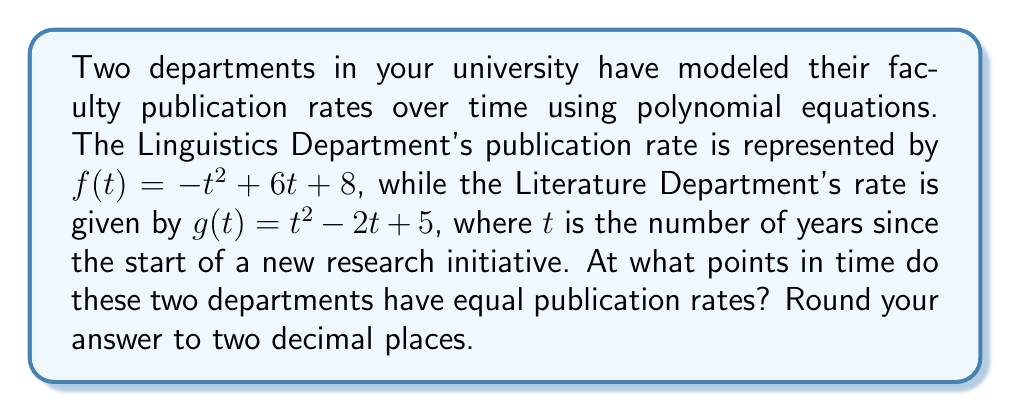Help me with this question. To find the intersection points of these two polynomial functions, we need to solve the equation $f(t) = g(t)$:

1) Set up the equation:
   $-t^2 + 6t + 8 = t^2 - 2t + 5$

2) Rearrange all terms to one side:
   $-t^2 + 6t + 8 - (t^2 - 2t + 5) = 0$
   $-2t^2 + 8t + 3 = 0$

3) Simplify by dividing all terms by -2:
   $t^2 - 4t - 1.5 = 0$

4) This is a quadratic equation. We can solve it using the quadratic formula:
   $t = \frac{-b \pm \sqrt{b^2 - 4ac}}{2a}$

   Where $a = 1$, $b = -4$, and $c = -1.5$

5) Substituting these values:
   $t = \frac{4 \pm \sqrt{(-4)^2 - 4(1)(-1.5)}}{2(1)}$
   $t = \frac{4 \pm \sqrt{16 + 6}}{2}$
   $t = \frac{4 \pm \sqrt{22}}{2}$

6) Simplify:
   $t = 2 \pm \frac{\sqrt{22}}{2}$

7) Calculate the two solutions:
   $t_1 = 2 + \frac{\sqrt{22}}{2} \approx 4.35$
   $t_2 = 2 - \frac{\sqrt{22}}{2} \approx -0.35$

8) Since time cannot be negative in this context, we discard the negative solution.
Answer: The Linguistics and Literature Departments have equal publication rates after approximately 4.35 years. 